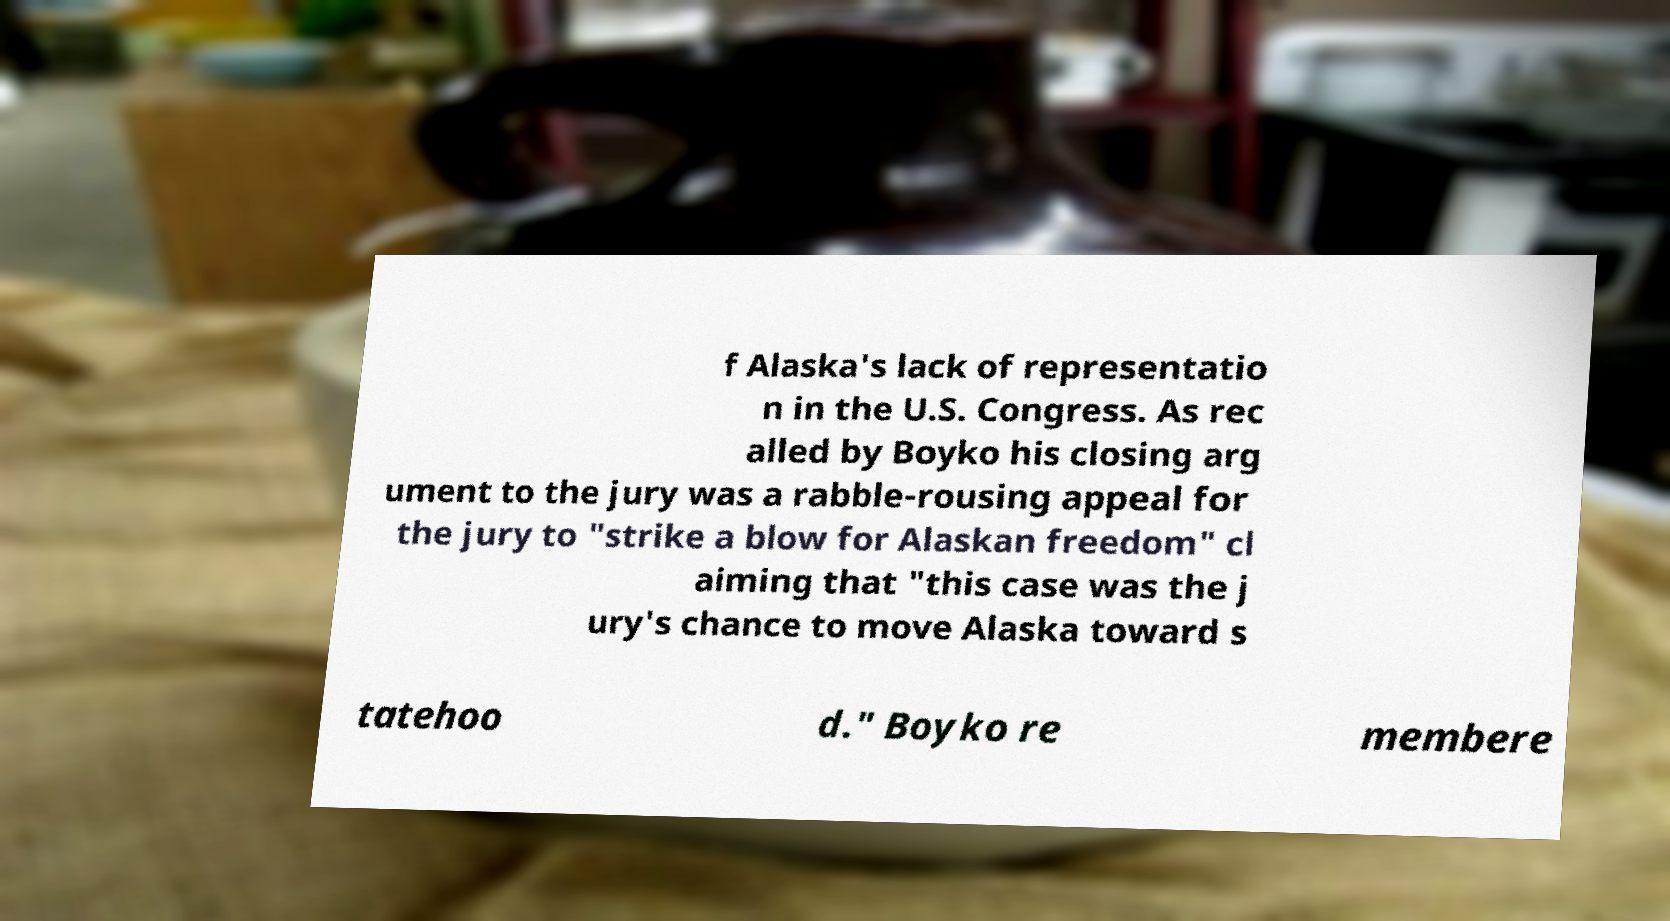Can you accurately transcribe the text from the provided image for me? f Alaska's lack of representatio n in the U.S. Congress. As rec alled by Boyko his closing arg ument to the jury was a rabble-rousing appeal for the jury to "strike a blow for Alaskan freedom" cl aiming that "this case was the j ury's chance to move Alaska toward s tatehoo d." Boyko re membere 